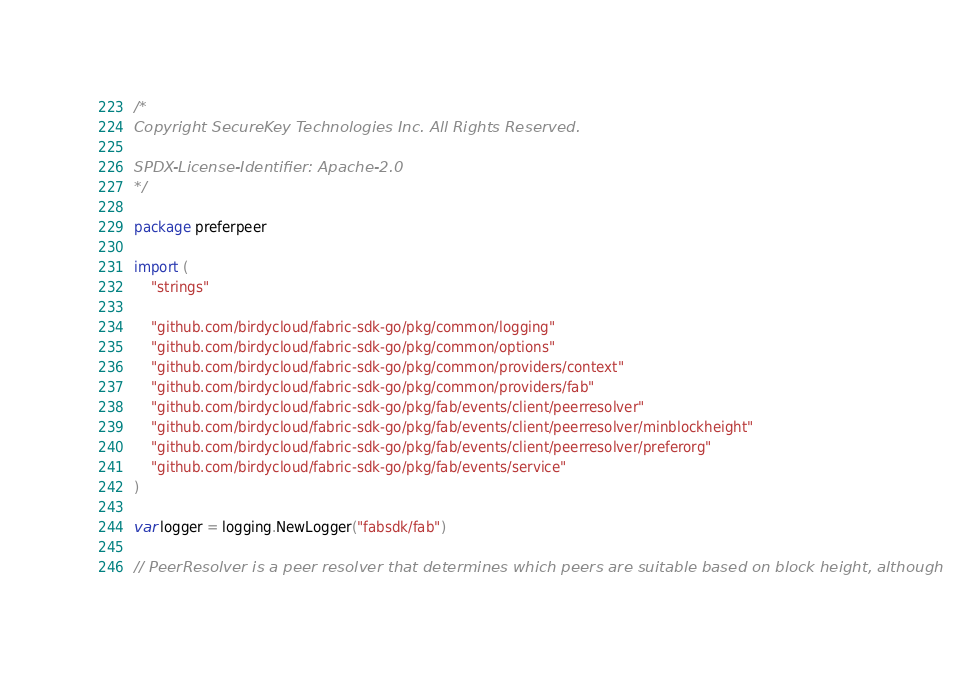<code> <loc_0><loc_0><loc_500><loc_500><_Go_>/*
Copyright SecureKey Technologies Inc. All Rights Reserved.

SPDX-License-Identifier: Apache-2.0
*/

package preferpeer

import (
	"strings"

	"github.com/birdycloud/fabric-sdk-go/pkg/common/logging"
	"github.com/birdycloud/fabric-sdk-go/pkg/common/options"
	"github.com/birdycloud/fabric-sdk-go/pkg/common/providers/context"
	"github.com/birdycloud/fabric-sdk-go/pkg/common/providers/fab"
	"github.com/birdycloud/fabric-sdk-go/pkg/fab/events/client/peerresolver"
	"github.com/birdycloud/fabric-sdk-go/pkg/fab/events/client/peerresolver/minblockheight"
	"github.com/birdycloud/fabric-sdk-go/pkg/fab/events/client/peerresolver/preferorg"
	"github.com/birdycloud/fabric-sdk-go/pkg/fab/events/service"
)

var logger = logging.NewLogger("fabsdk/fab")

// PeerResolver is a peer resolver that determines which peers are suitable based on block height, although</code> 